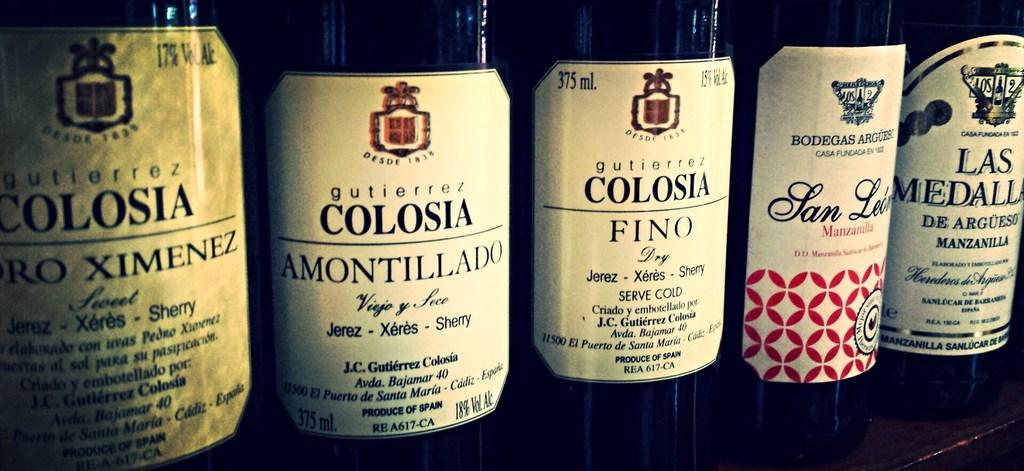Provide a one-sentence caption for the provided image. An assortment of five wine bottles with Colosia on three of the labels. 